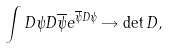<formula> <loc_0><loc_0><loc_500><loc_500>\int D \psi D \overline { \psi } e ^ { \overline { \psi } D \psi } \rightarrow \det D ,</formula> 